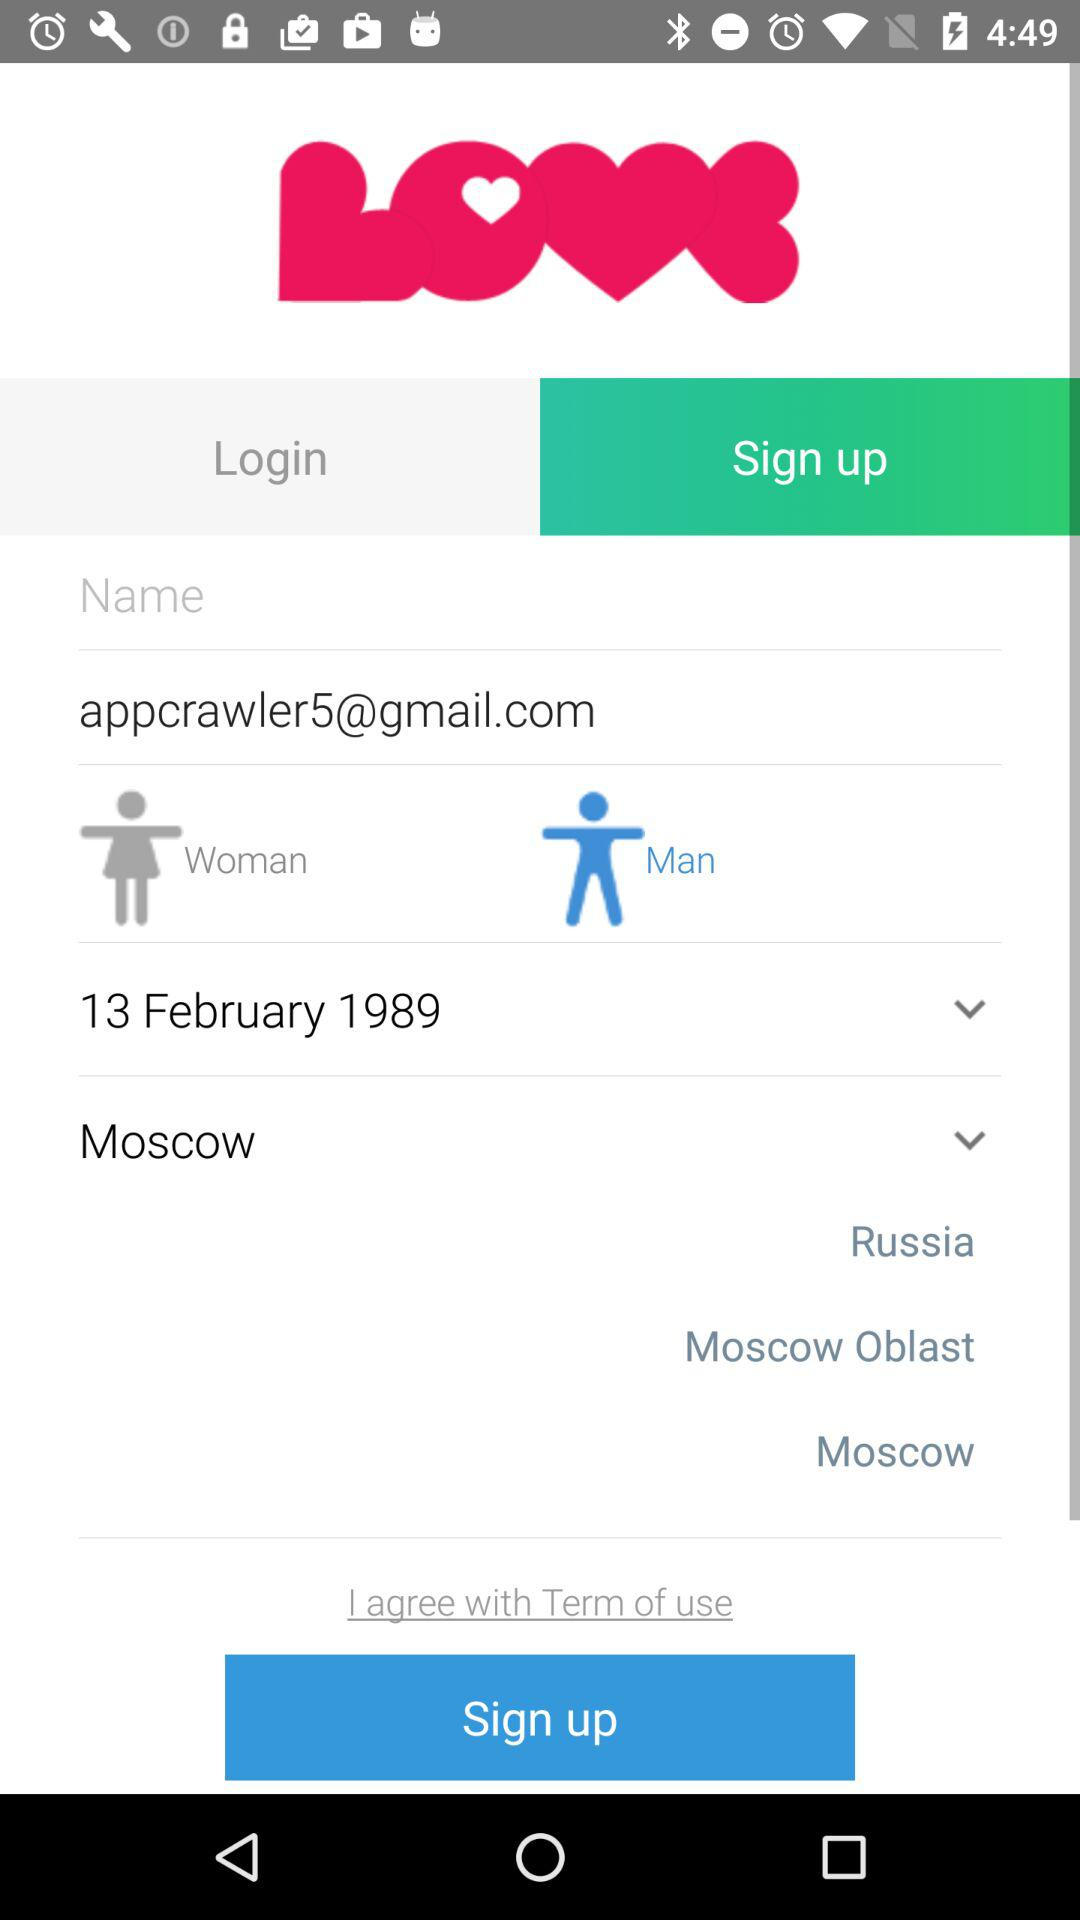What is the email address? The email address is appcrawler5@gmail.com. 